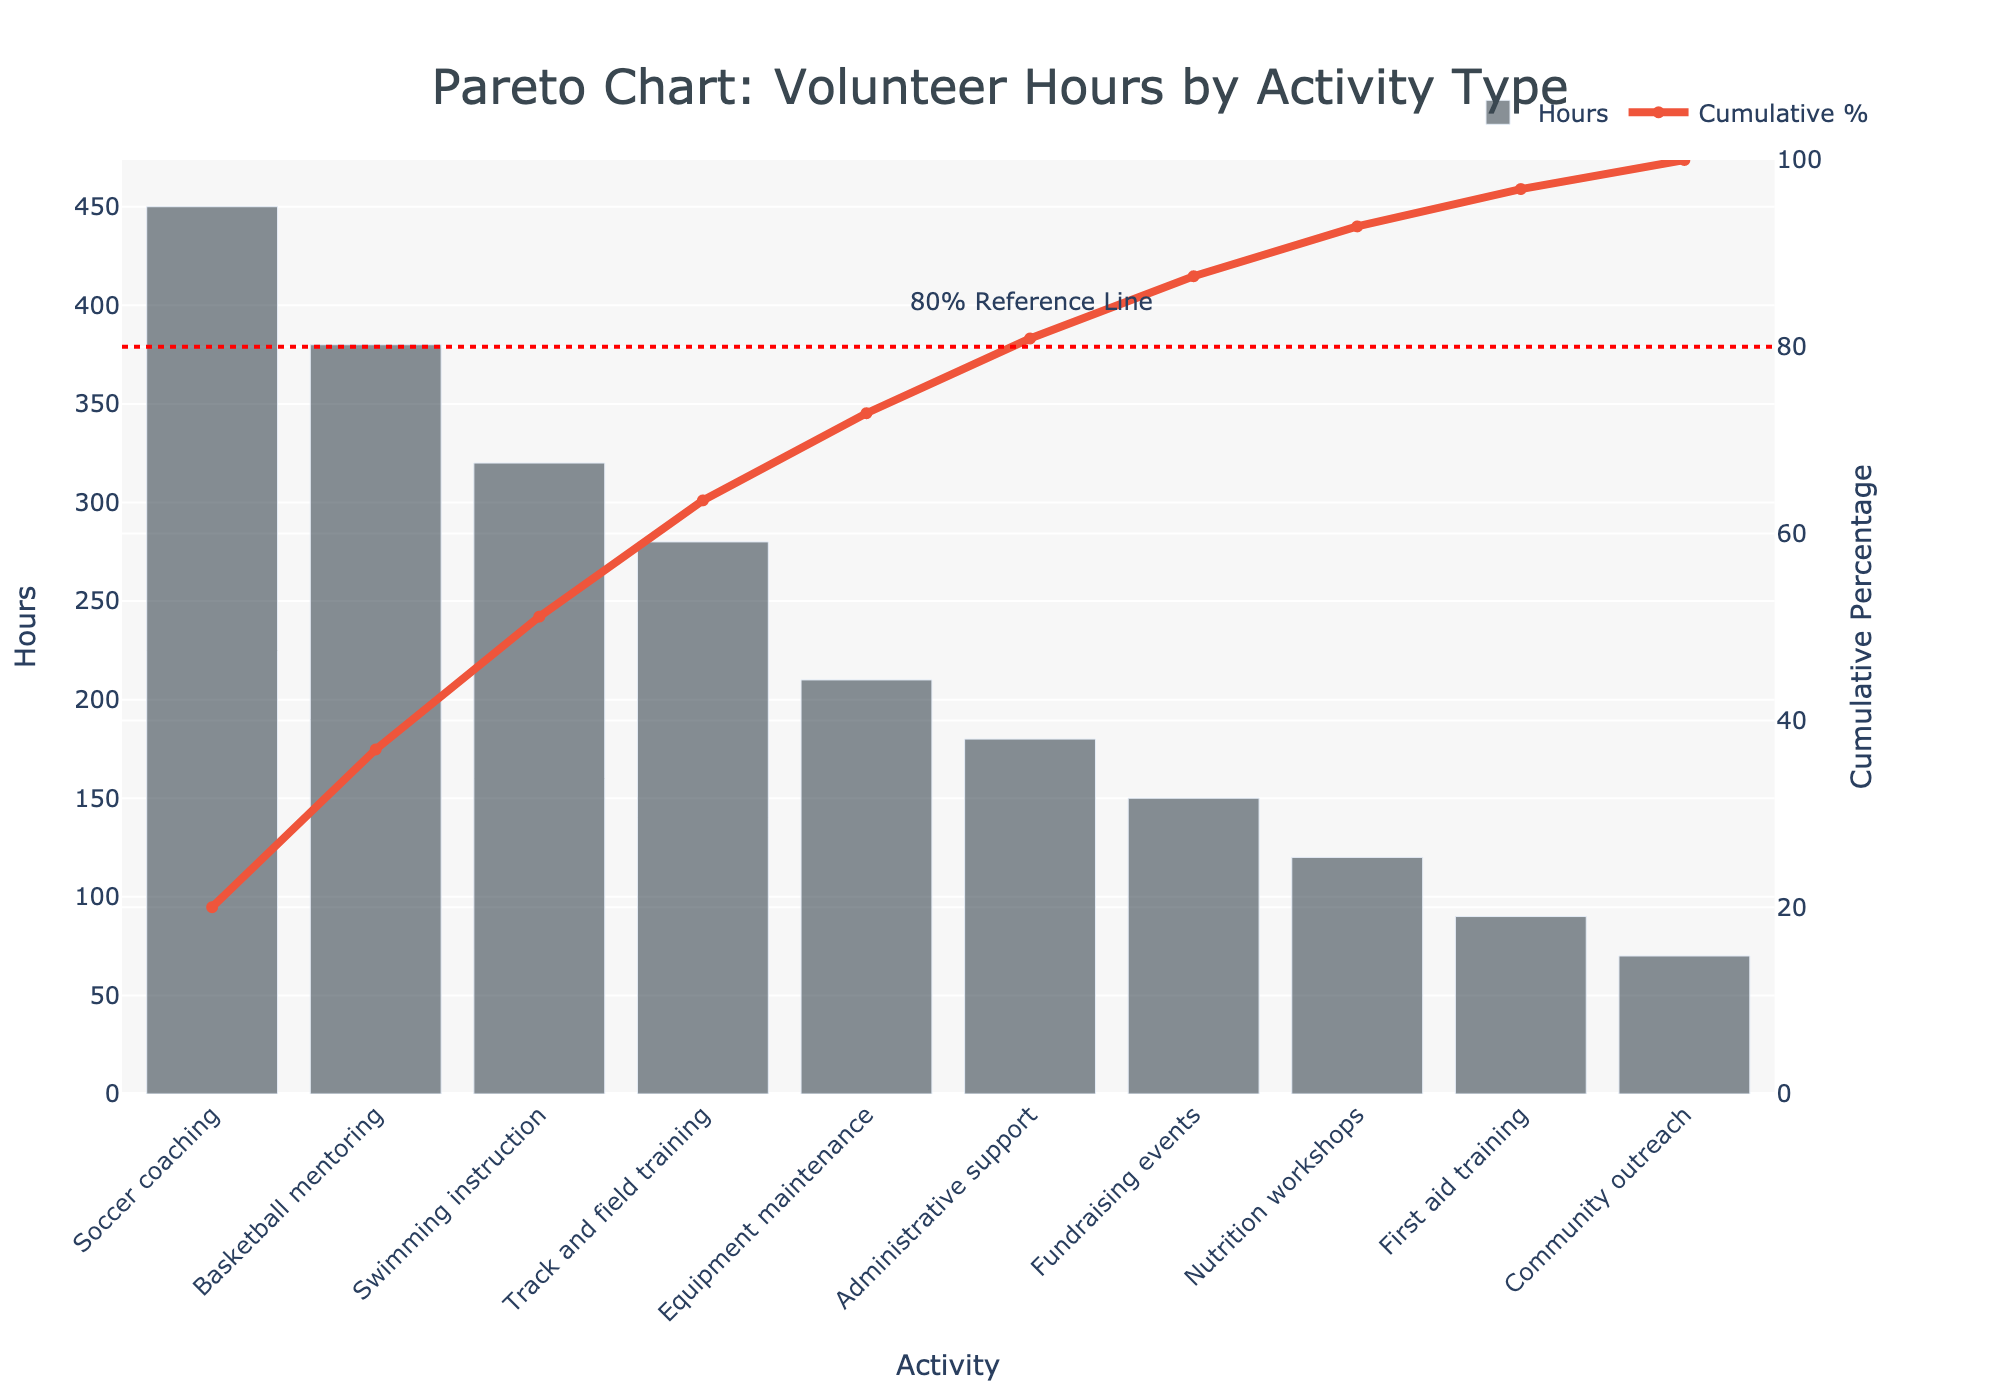What's the activity with the highest number of volunteer hours? The activity with the highest number of volunteer hours is shown as the tallest bar in the bar chart. It is labeled at the bottom axis.
Answer: Soccer coaching How many hours were contributed to Fundraising events? To find the volunteer hours for Fundraising events, locate the corresponding bar for Fundraising events and read off the height, which is labeled as the y-axis value.
Answer: 150 What is the cumulative percentage of hours contributed by the top three activities? First, identify the top three activities (Soccer coaching, Basketball mentoring, and Swimming instruction) and their cumulative percentage line point. Then, read the value along the right y-axis (Cumulative Percentage).
Answer: 66.9% Which activity contributes just above 70% of the cumulative volunteer hours? Follow the cumulative percentage line up to just above 70% on the right y-axis and identify the corresponding activity on the x-axis.
Answer: Track and field training What is the total number of volunteer hours contributed by Nutrition workshops and Equipment maintenance? Locate the bars for Nutrition workshops (120 hours) and Equipment maintenance (210 hours), then sum their heights: 120 + 210.
Answer: 330 Which activity has approximately half the volunteer hours compared to Soccer coaching? Identify the volunteer hours for Soccer coaching (450 hours) and find the activity with about half that value (~225 hours).
Answer: Equipment maintenance What percentage of activities contribute to approximately 80% of the total volunteer hours? Follow the cumulative percentage line up to 80% on the right y-axis, identify the number of activities at that point, and then divide by the total number of activities. There are 5 activities contributing up to 80%. The percentage is (5/10) * 100%.
Answer: 50% What is the difference in volunteer hours between the highest and lowest contributing activities? Identify the hours for the highest (Soccer coaching with 450 hours) and lowest (Community outreach with 70 hours) contributing activities, then subtract the latter from the former: 450 - 70.
Answer: 380 Between Fundraising events and Administrative support, which activity has more volunteer hours, and how many more? Identify the volunteer hours for both activities (Fundraising events with 150 hours, Administrative support with 180 hours), and subtract the smaller from the larger: 180 - 150.
Answer: Administrative support, 30 hours 